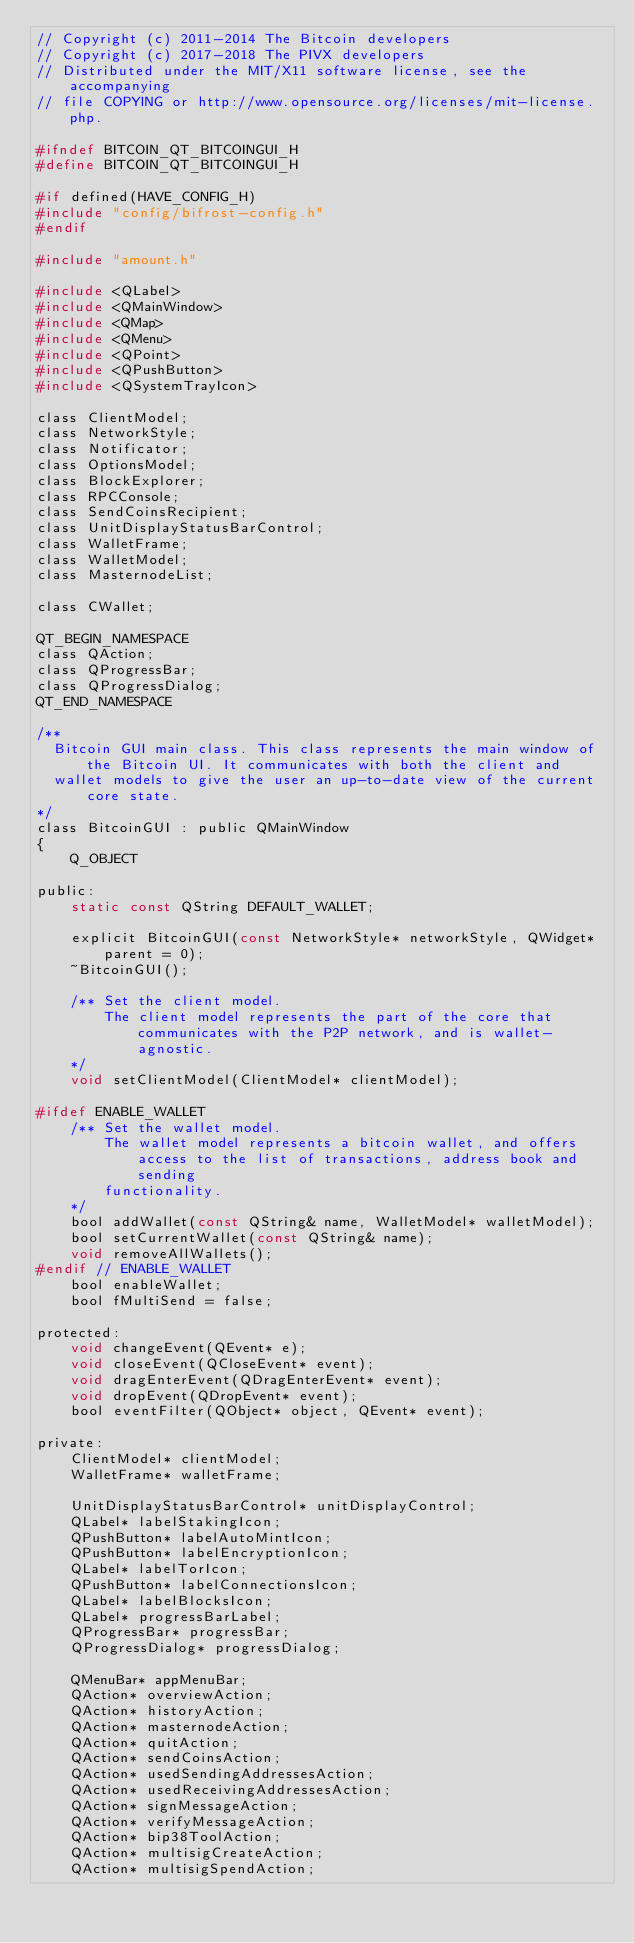Convert code to text. <code><loc_0><loc_0><loc_500><loc_500><_C_>// Copyright (c) 2011-2014 The Bitcoin developers
// Copyright (c) 2017-2018 The PIVX developers
// Distributed under the MIT/X11 software license, see the accompanying
// file COPYING or http://www.opensource.org/licenses/mit-license.php.

#ifndef BITCOIN_QT_BITCOINGUI_H
#define BITCOIN_QT_BITCOINGUI_H

#if defined(HAVE_CONFIG_H)
#include "config/bifrost-config.h"
#endif

#include "amount.h"

#include <QLabel>
#include <QMainWindow>
#include <QMap>
#include <QMenu>
#include <QPoint>
#include <QPushButton>
#include <QSystemTrayIcon>

class ClientModel;
class NetworkStyle;
class Notificator;
class OptionsModel;
class BlockExplorer;
class RPCConsole;
class SendCoinsRecipient;
class UnitDisplayStatusBarControl;
class WalletFrame;
class WalletModel;
class MasternodeList;

class CWallet;

QT_BEGIN_NAMESPACE
class QAction;
class QProgressBar;
class QProgressDialog;
QT_END_NAMESPACE

/**
  Bitcoin GUI main class. This class represents the main window of the Bitcoin UI. It communicates with both the client and
  wallet models to give the user an up-to-date view of the current core state.
*/
class BitcoinGUI : public QMainWindow
{
    Q_OBJECT

public:
    static const QString DEFAULT_WALLET;

    explicit BitcoinGUI(const NetworkStyle* networkStyle, QWidget* parent = 0);
    ~BitcoinGUI();

    /** Set the client model.
        The client model represents the part of the core that communicates with the P2P network, and is wallet-agnostic.
    */
    void setClientModel(ClientModel* clientModel);

#ifdef ENABLE_WALLET
    /** Set the wallet model.
        The wallet model represents a bitcoin wallet, and offers access to the list of transactions, address book and sending
        functionality.
    */
    bool addWallet(const QString& name, WalletModel* walletModel);
    bool setCurrentWallet(const QString& name);
    void removeAllWallets();
#endif // ENABLE_WALLET
    bool enableWallet;
    bool fMultiSend = false;

protected:
    void changeEvent(QEvent* e);
    void closeEvent(QCloseEvent* event);
    void dragEnterEvent(QDragEnterEvent* event);
    void dropEvent(QDropEvent* event);
    bool eventFilter(QObject* object, QEvent* event);

private:
    ClientModel* clientModel;
    WalletFrame* walletFrame;

    UnitDisplayStatusBarControl* unitDisplayControl;
    QLabel* labelStakingIcon;
    QPushButton* labelAutoMintIcon;
    QPushButton* labelEncryptionIcon;
    QLabel* labelTorIcon;
    QPushButton* labelConnectionsIcon;
    QLabel* labelBlocksIcon;
    QLabel* progressBarLabel;
    QProgressBar* progressBar;
    QProgressDialog* progressDialog;

    QMenuBar* appMenuBar;
    QAction* overviewAction;
    QAction* historyAction;
    QAction* masternodeAction;
    QAction* quitAction;
    QAction* sendCoinsAction;
    QAction* usedSendingAddressesAction;
    QAction* usedReceivingAddressesAction;
    QAction* signMessageAction;
    QAction* verifyMessageAction;
    QAction* bip38ToolAction;
    QAction* multisigCreateAction;
    QAction* multisigSpendAction;</code> 